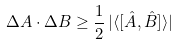Convert formula to latex. <formula><loc_0><loc_0><loc_500><loc_500>\Delta A \cdot \Delta B \geq \frac { 1 } { 2 } \, | { \langle { [ { \hat { A } , \hat { B } } ] } \rangle } |</formula> 